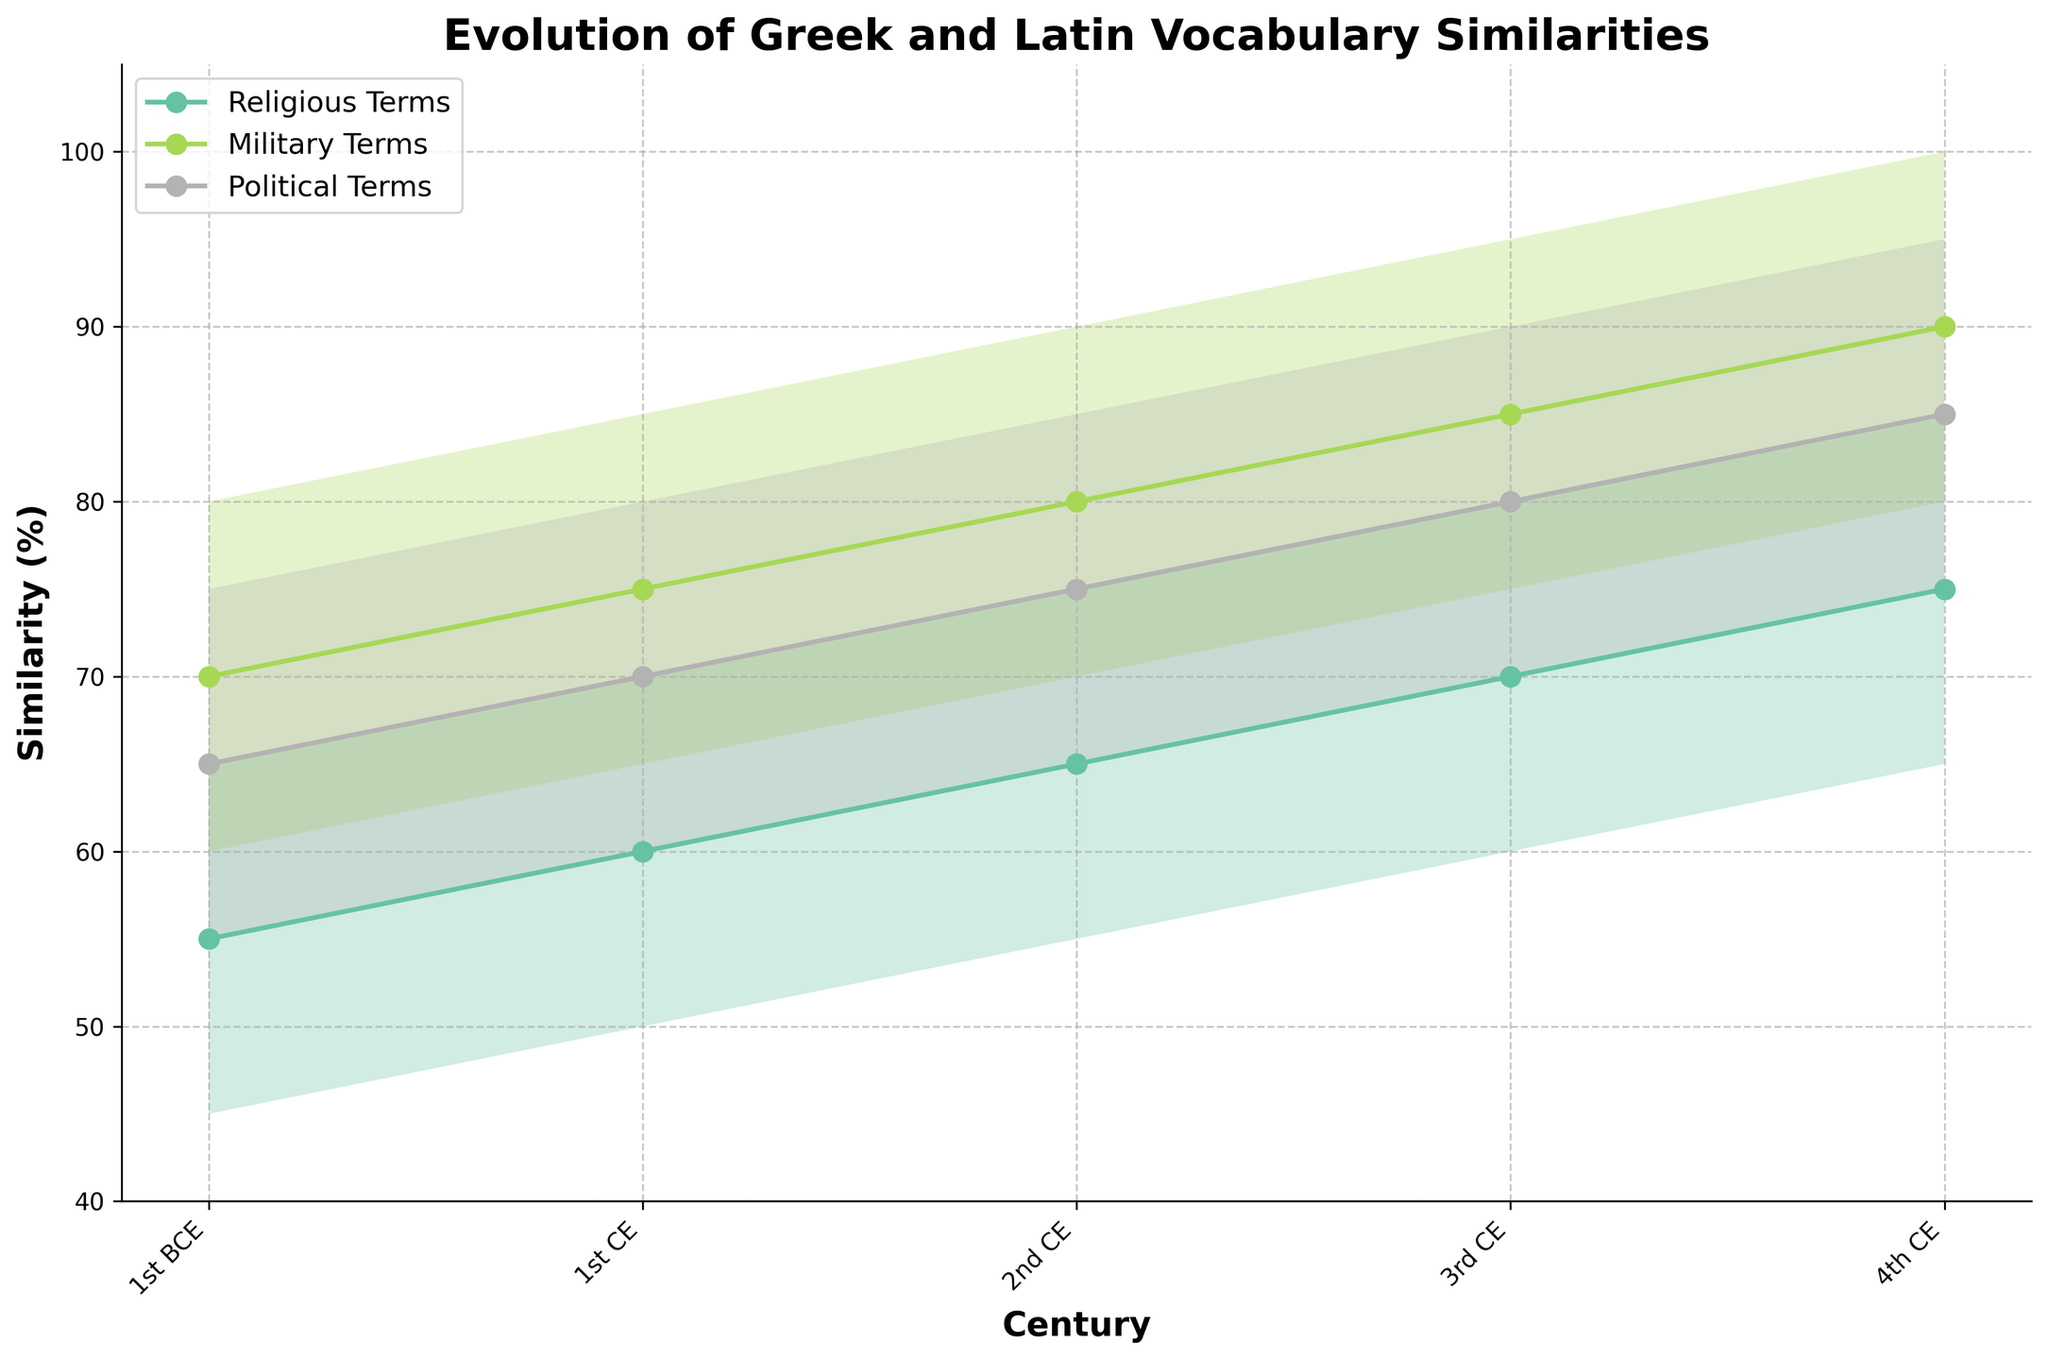What is the title of the plot? The title of the plot is always prominently displayed at the top of the figure, typically in bold font. In this case, the title is "Evolution of Greek and Latin Vocabulary Similarities".
Answer: Evolution of Greek and Latin Vocabulary Similarities What time period does the x-axis cover? The x-axis shows the centuries over which the vocabulary similarities are measured. It starts from the 1st century BCE and goes up to the 4th century CE.
Answer: 1st BCE to 4th CE Which category shows the highest similarity range in the 4th century CE? By looking at the filled areas for the 4th century CE, the 'Military Terms' category shows the highest similarity range from 80% to 100%.
Answer: Military Terms In which century do 'Religious Terms' show the largest increase in mid similarity value? By examining the mid similarity values depicted by the markers, 'Religious Terms' show the largest increase from the 1st century BCE (55%) to the 1st century CE (60%), which is an increase of 5%.
Answer: 1st BCE to 1st CE What is the approximate average similarity range for 'Political Terms' in the 3rd century CE? The similarity range for 'Political Terms' in the 3rd century CE goes from 70% to 90%. The approximate average can be calculated as (70 + 90) / 2 = 80%.
Answer: 80% Do the 'Military Terms' maintain a higher mid similarity value compared to 'Religious Terms' across all centuries? By comparing each century, 'Military Terms' always have a higher mid similarity value than 'Religious Terms': 1st BCE (70 vs 55), 1st CE (75 vs 60), 2nd CE (80 vs 65), 3rd CE (85 vs 70), and 4th CE (90 vs 75).
Answer: Yes What trend is observed in the similarity of 'Political Terms' from the 1st BCE to the 4th CE? 'Political Terms' show a consistent upward trend in similarity: 1st BCE (65%), 1st CE (70%), 2nd CE (75%), 3rd CE (80%), and 4th CE (85%).
Answer: Upward trend How does the range of similarity for 'Religious Terms' in the 2nd century CE compare to the 1st century BCE? In the 2nd century CE, 'Religious Terms' have a similarity range of 55% to 75%, compared to 45% to 65% in the 1st century BCE. This shows an overall shift upwards.
Answer: Upward shift Which category has the most consistent mid similarity value increase over the centuries? By plotting the mid values, it is clear that ‘Military Terms’ show the most consistent increase: 1st BCE (70), 1st CE (75), 2nd CE (80), 3rd CE (85), and 4th CE (90).
Answer: Military Terms 